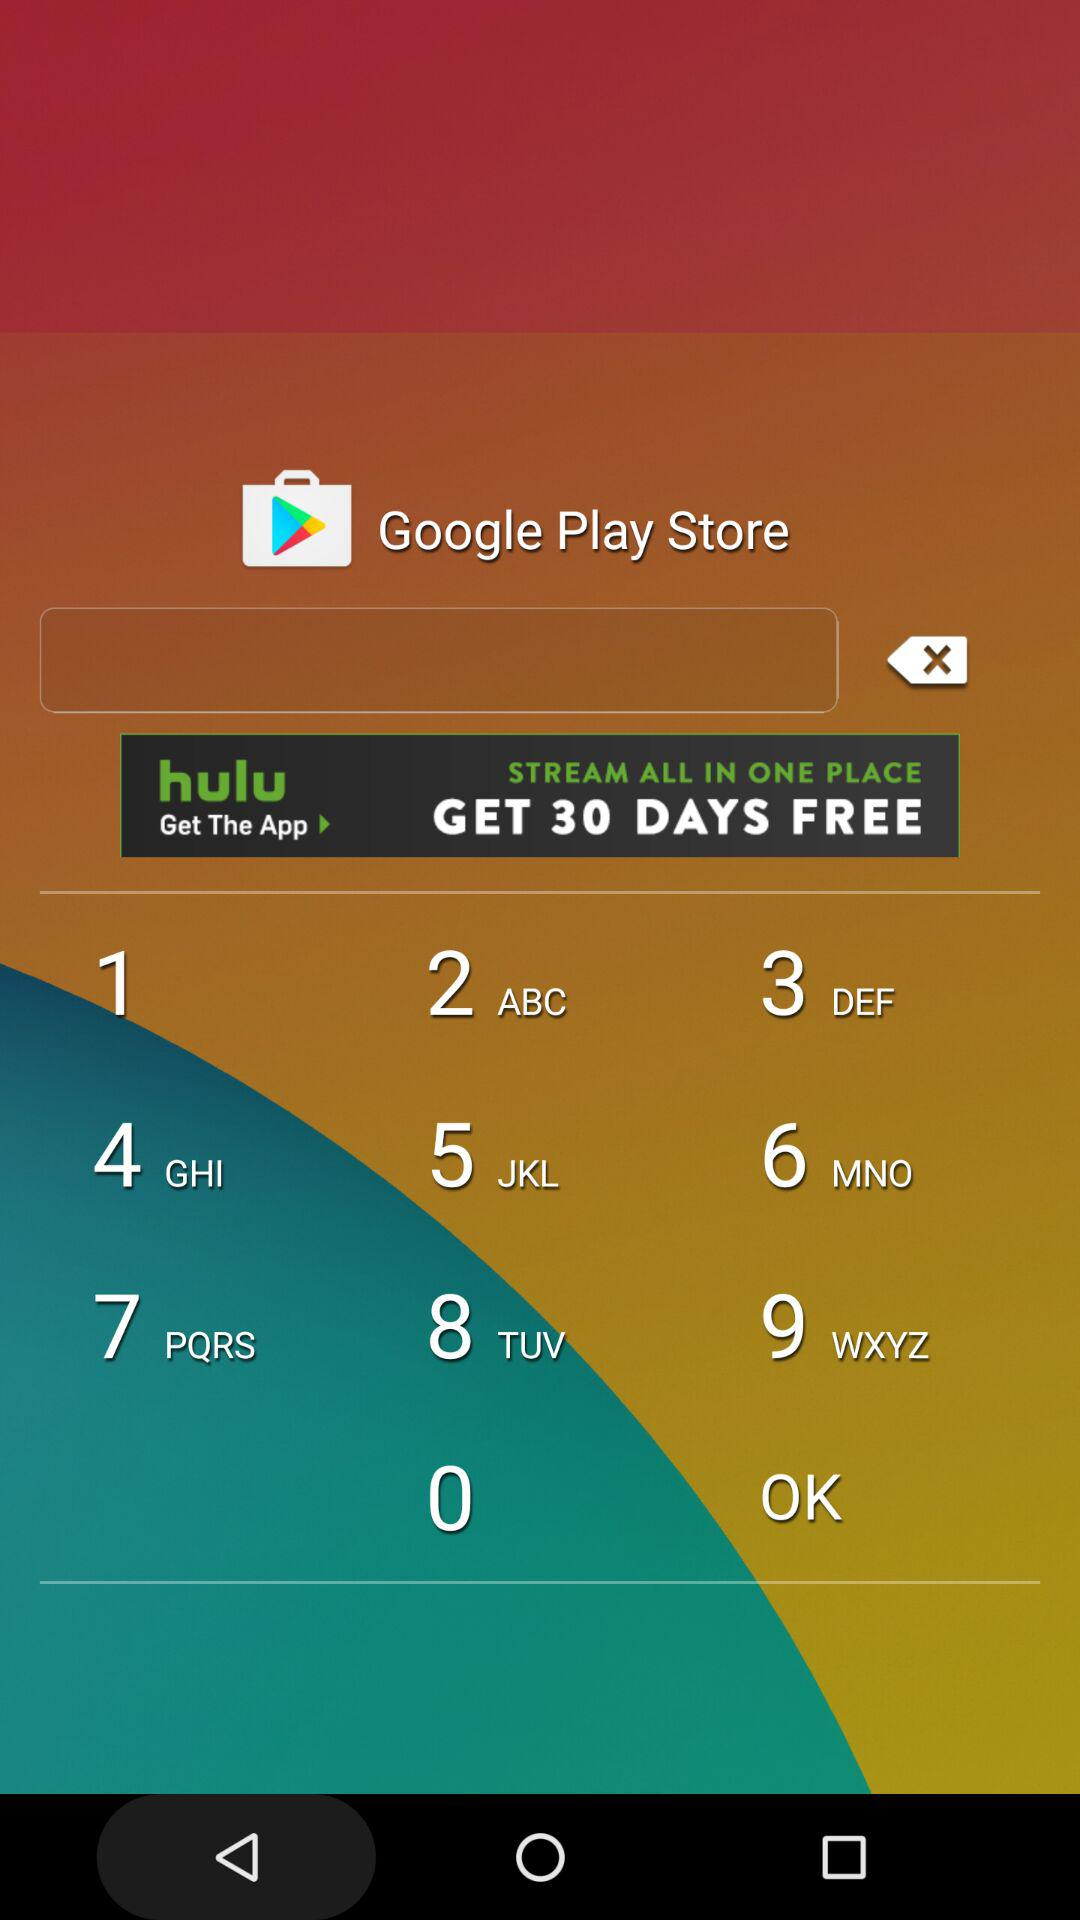How many races are there?
Answer the question using a single word or phrase. 4 